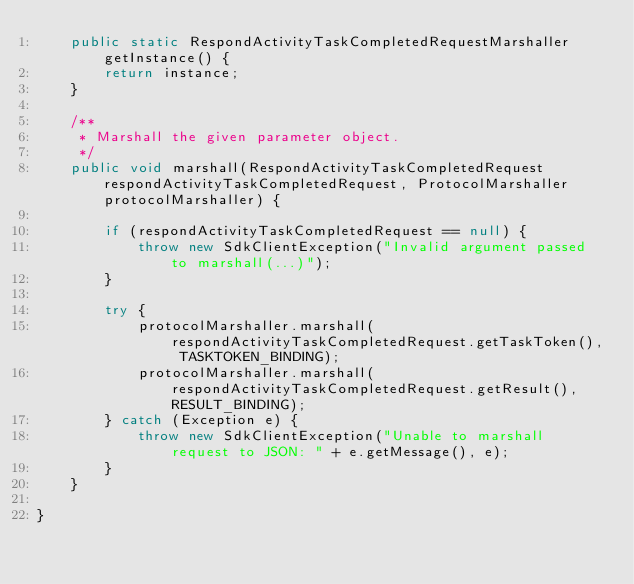<code> <loc_0><loc_0><loc_500><loc_500><_Java_>    public static RespondActivityTaskCompletedRequestMarshaller getInstance() {
        return instance;
    }

    /**
     * Marshall the given parameter object.
     */
    public void marshall(RespondActivityTaskCompletedRequest respondActivityTaskCompletedRequest, ProtocolMarshaller protocolMarshaller) {

        if (respondActivityTaskCompletedRequest == null) {
            throw new SdkClientException("Invalid argument passed to marshall(...)");
        }

        try {
            protocolMarshaller.marshall(respondActivityTaskCompletedRequest.getTaskToken(), TASKTOKEN_BINDING);
            protocolMarshaller.marshall(respondActivityTaskCompletedRequest.getResult(), RESULT_BINDING);
        } catch (Exception e) {
            throw new SdkClientException("Unable to marshall request to JSON: " + e.getMessage(), e);
        }
    }

}
</code> 